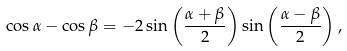Convert formula to latex. <formula><loc_0><loc_0><loc_500><loc_500>\cos \alpha - \cos \beta = - 2 \sin \left ( \frac { \alpha + \beta } { 2 } \right ) \sin \left ( \frac { \alpha - \beta } { 2 } \right ) ,</formula> 